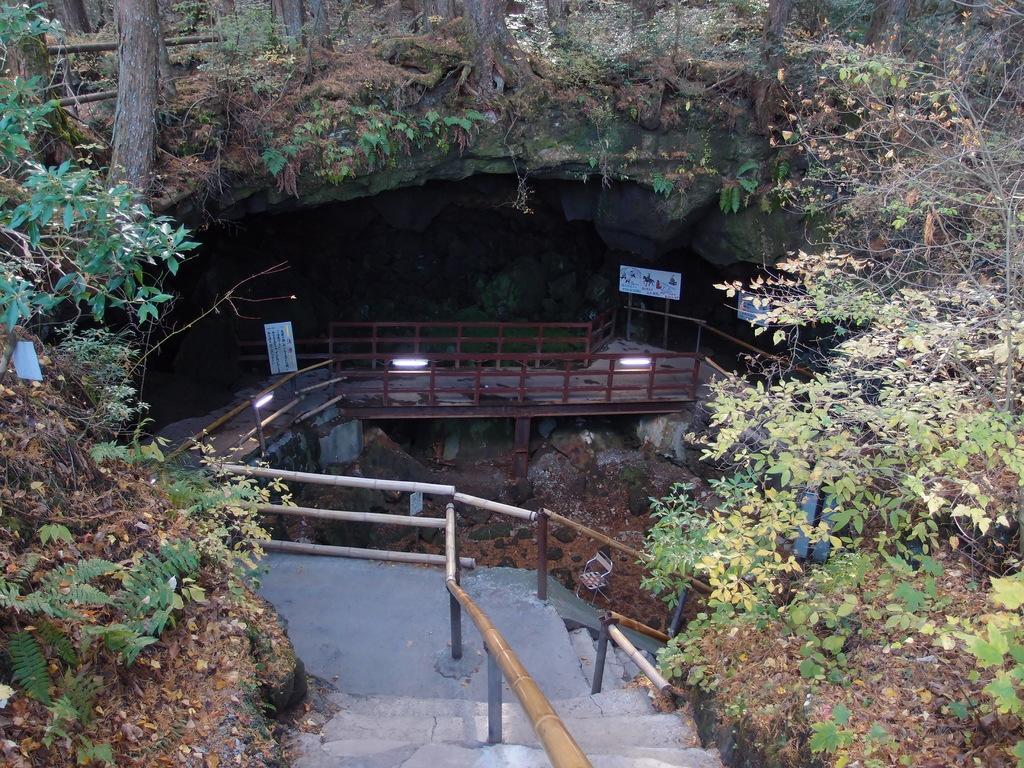Can you describe this image briefly? In this image we can see railing, planter, lights, boards and rocks. 